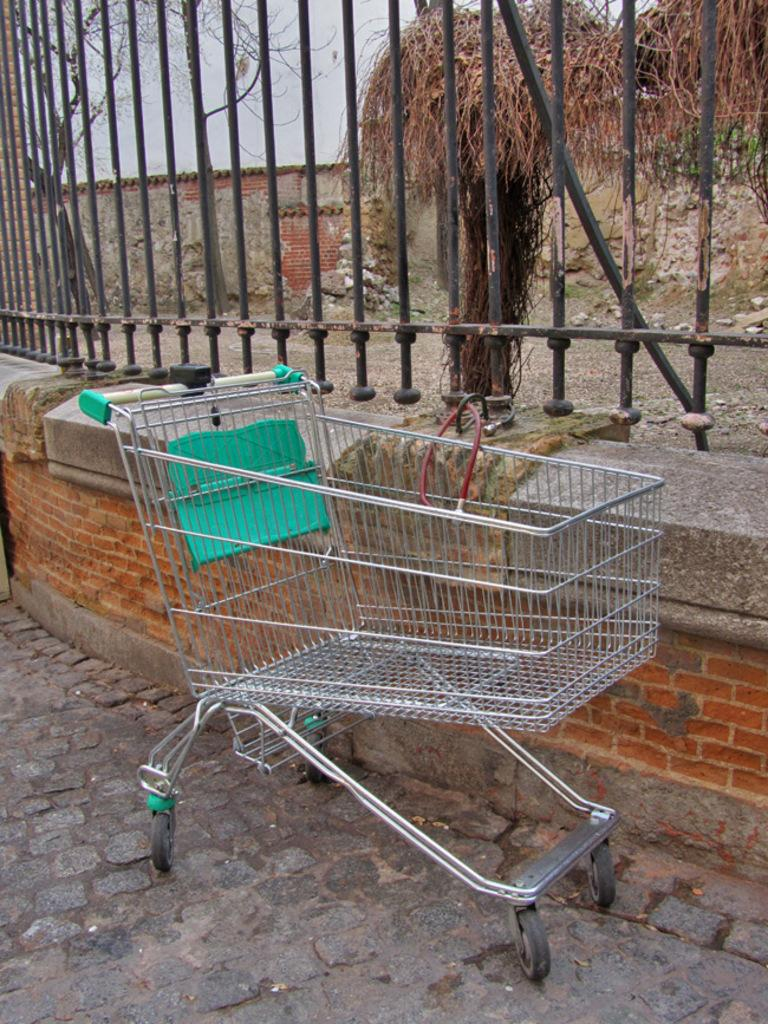What is located in the center of the image? There is a wall, a fence, and a shopping cart in the center of the image. What can be seen through the fence in the image? The sky, a house, stones, and a tree can be seen through the fence in the image. What type of map is visible on the wall in the image? There is no map visible on the wall in the image. What kind of music is being played by the band in the image? There is no band present in the image. 